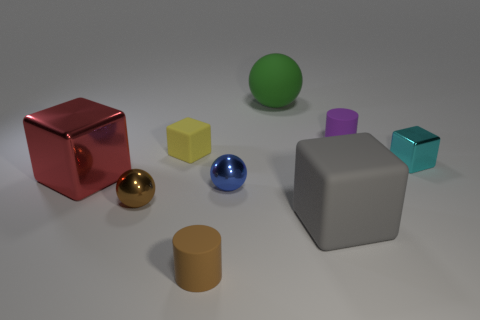There is a purple matte object; is it the same shape as the big matte object behind the cyan thing?
Keep it short and to the point. No. What number of objects are either metal objects on the left side of the tiny yellow matte thing or tiny matte objects that are behind the brown sphere?
Provide a short and direct response. 4. There is a object that is to the right of the purple cylinder; what shape is it?
Give a very brief answer. Cube. There is a brown thing to the right of the yellow block; is it the same shape as the gray object?
Offer a very short reply. No. How many objects are metallic objects that are to the right of the brown matte cylinder or tiny cyan blocks?
Offer a very short reply. 2. There is another big matte thing that is the same shape as the cyan object; what color is it?
Your response must be concise. Gray. Is there anything else of the same color as the big rubber ball?
Ensure brevity in your answer.  No. There is a sphere behind the tiny blue metal ball; how big is it?
Your response must be concise. Large. Is the color of the small shiny cube the same as the cylinder behind the small blue ball?
Give a very brief answer. No. How many other things are there of the same material as the big gray cube?
Your answer should be very brief. 4. 